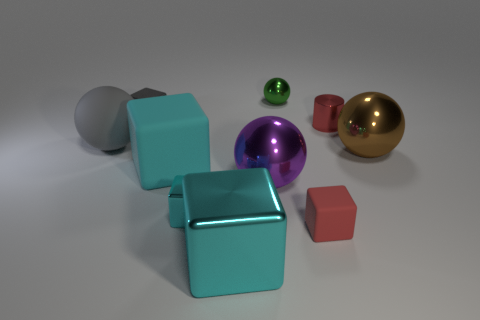How many cyan blocks must be subtracted to get 2 cyan blocks? 1 Subtract all tiny rubber cubes. How many cubes are left? 4 Subtract all purple balls. How many balls are left? 3 Subtract all brown cylinders. How many brown balls are left? 1 Subtract all cylinders. How many objects are left? 9 Subtract 4 balls. How many balls are left? 0 Subtract all red blocks. Subtract all yellow spheres. How many blocks are left? 4 Subtract all red metal cylinders. Subtract all tiny green shiny things. How many objects are left? 8 Add 3 blocks. How many blocks are left? 8 Add 2 large things. How many large things exist? 7 